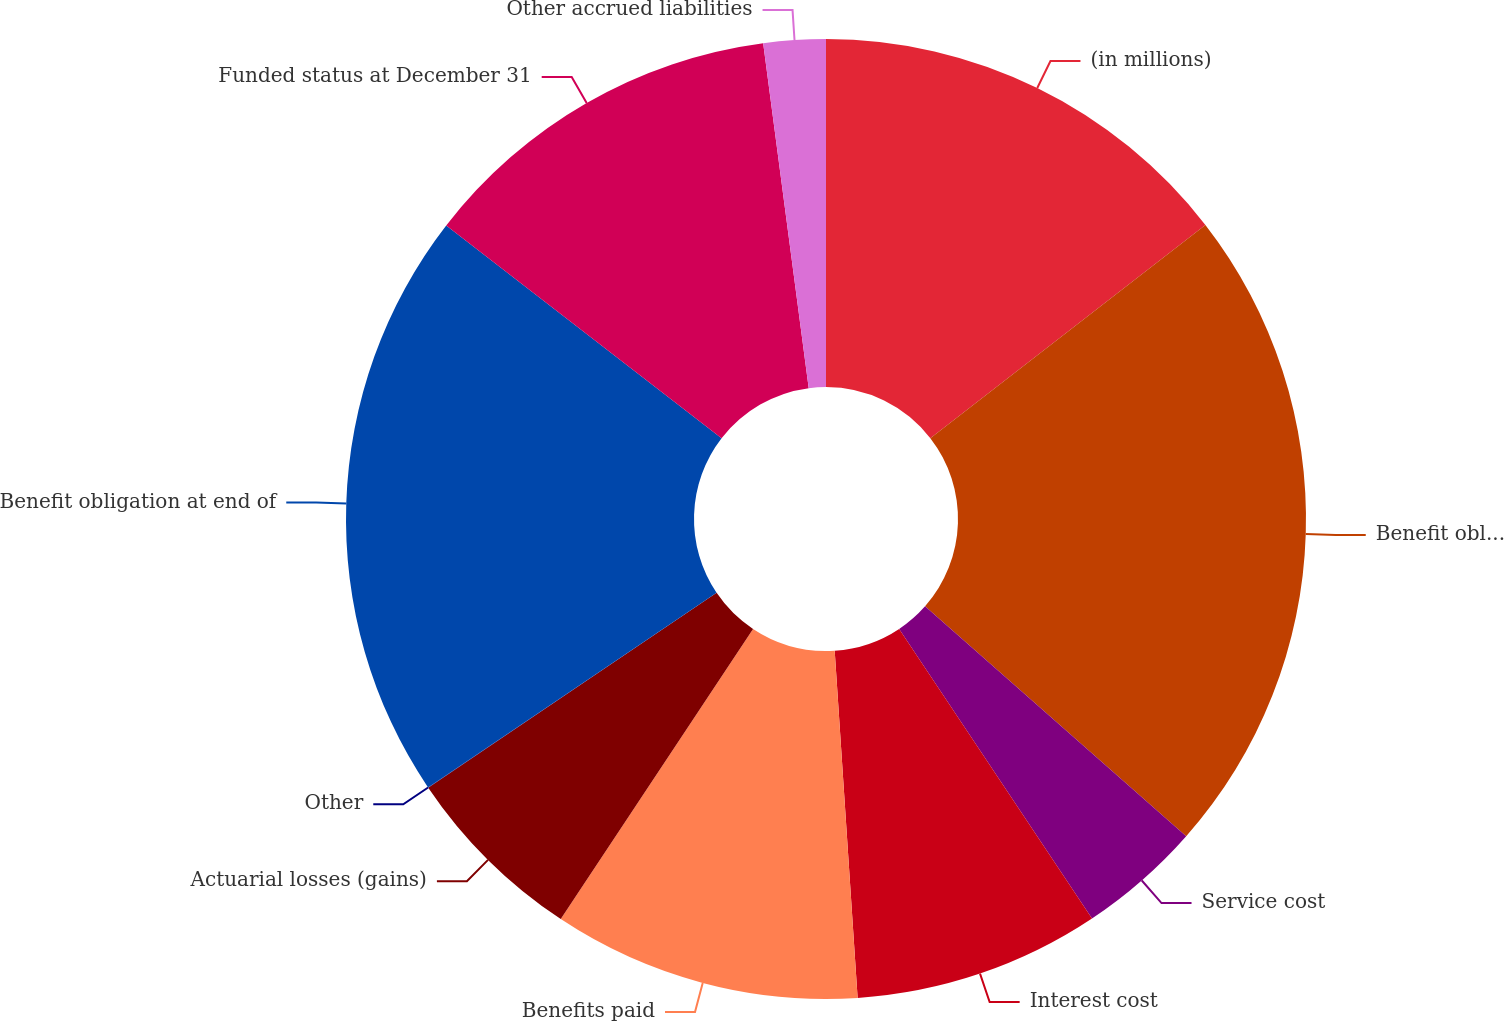Convert chart. <chart><loc_0><loc_0><loc_500><loc_500><pie_chart><fcel>(in millions)<fcel>Benefit obligation at<fcel>Service cost<fcel>Interest cost<fcel>Benefits paid<fcel>Actuarial losses (gains)<fcel>Other<fcel>Benefit obligation at end of<fcel>Funded status at December 31<fcel>Other accrued liabilities<nl><fcel>14.51%<fcel>21.99%<fcel>4.16%<fcel>8.3%<fcel>10.37%<fcel>6.23%<fcel>0.01%<fcel>19.92%<fcel>12.44%<fcel>2.09%<nl></chart> 